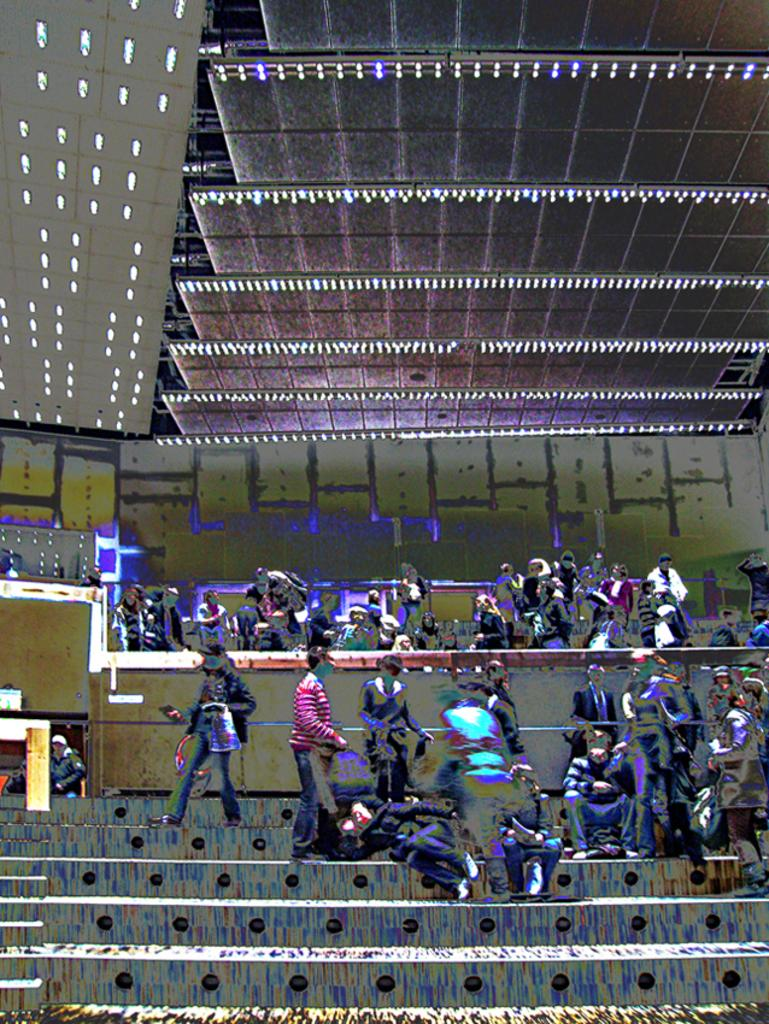Who or what can be seen in the image? There are people in the image. What architectural feature is present in the image? There are steps in the image. What can be used to provide illumination in the image? There are lights in the image. What type of sponge is being used by the people in the image? There is no sponge present in the image. What fact can be learned about the people in the image? The provided facts do not offer any specific information about the people in the image, so it is not possible to answer this question definitively. 